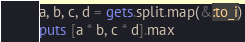<code> <loc_0><loc_0><loc_500><loc_500><_Ruby_>a, b, c, d = gets.split.map(&:to_i)
puts [a * b, c * d].max</code> 